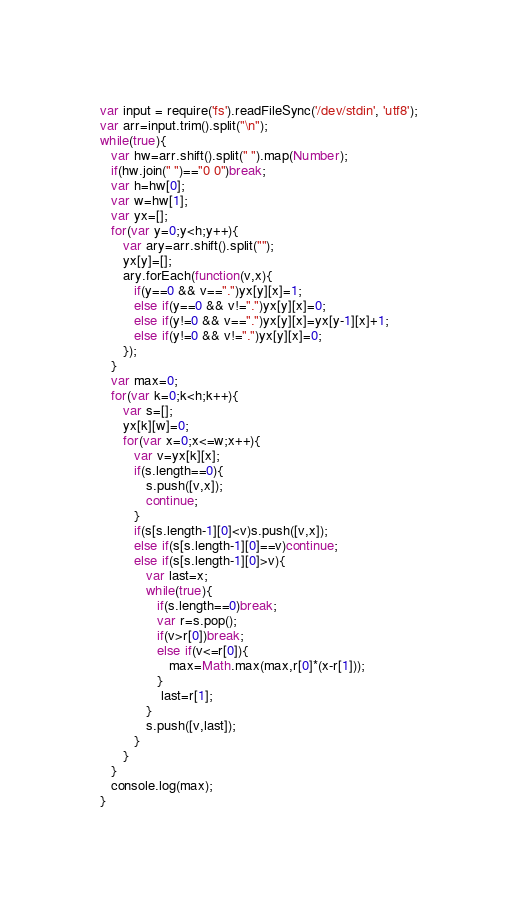<code> <loc_0><loc_0><loc_500><loc_500><_JavaScript_>var input = require('fs').readFileSync('/dev/stdin', 'utf8');
var arr=input.trim().split("\n");
while(true){
   var hw=arr.shift().split(" ").map(Number);
   if(hw.join(" ")=="0 0")break;
   var h=hw[0];
   var w=hw[1];
   var yx=[];
   for(var y=0;y<h;y++){
      var ary=arr.shift().split("");
      yx[y]=[];
      ary.forEach(function(v,x){
         if(y==0 && v==".")yx[y][x]=1;
         else if(y==0 && v!=".")yx[y][x]=0;
         else if(y!=0 && v==".")yx[y][x]=yx[y-1][x]+1;
         else if(y!=0 && v!=".")yx[y][x]=0;
      });
   }
   var max=0;
   for(var k=0;k<h;k++){
      var s=[];
      yx[k][w]=0;
      for(var x=0;x<=w;x++){
         var v=yx[k][x];
         if(s.length==0){
            s.push([v,x]);
            continue;
         }
         if(s[s.length-1][0]<v)s.push([v,x]);
         else if(s[s.length-1][0]==v)continue;
         else if(s[s.length-1][0]>v){
            var last=x;
            while(true){
               if(s.length==0)break;
               var r=s.pop();
               if(v>r[0])break;
               else if(v<=r[0]){
                  max=Math.max(max,r[0]*(x-r[1]));
               }
                last=r[1];
            }
            s.push([v,last]);
         }
      }
   }
   console.log(max);
}</code> 